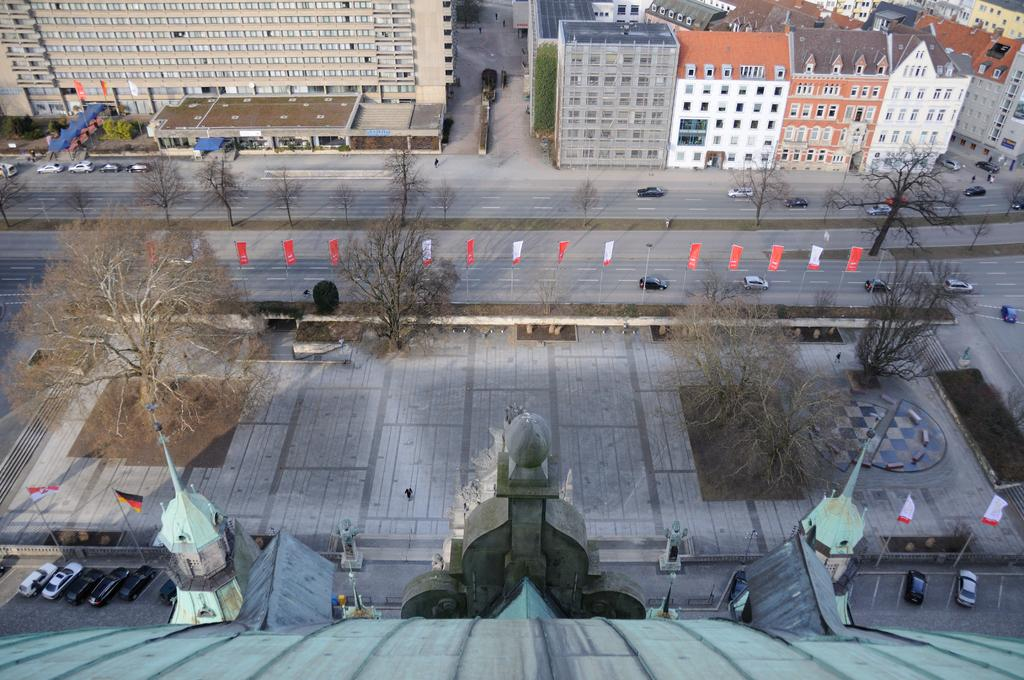What type of natural elements can be seen in the image? There are trees and plants in the image. What man-made structures are visible in the image? There are banners, flags on poles, buildings, and vehicles in the image. What type of surface can be seen in the image? There is a road in the image. What type of muscle is being exercised by the trees in the image? There is no muscle present in the image, as trees are plants and do not have muscles. 